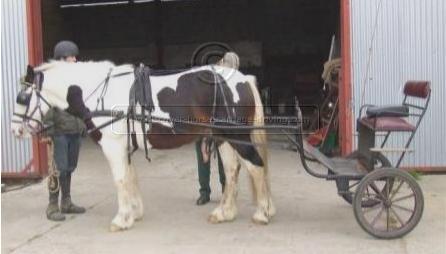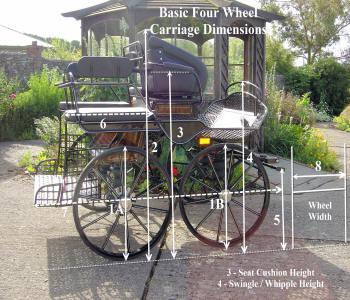The first image is the image on the left, the second image is the image on the right. For the images displayed, is the sentence "At least one image shows a cart that is not hooked up to a horse." factually correct? Answer yes or no. Yes. The first image is the image on the left, the second image is the image on the right. Given the left and right images, does the statement "There is a person in the image on the right." hold true? Answer yes or no. No. 